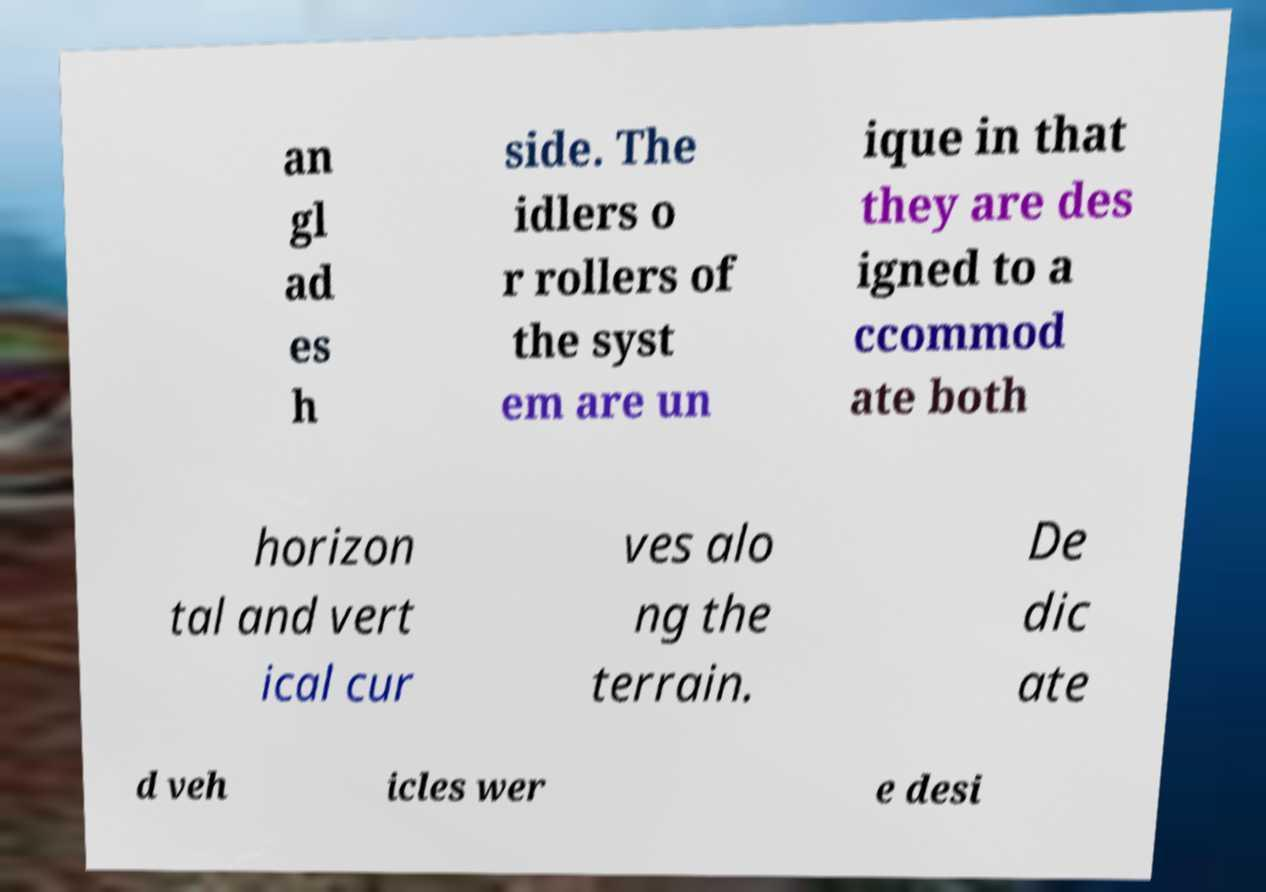For documentation purposes, I need the text within this image transcribed. Could you provide that? an gl ad es h side. The idlers o r rollers of the syst em are un ique in that they are des igned to a ccommod ate both horizon tal and vert ical cur ves alo ng the terrain. De dic ate d veh icles wer e desi 